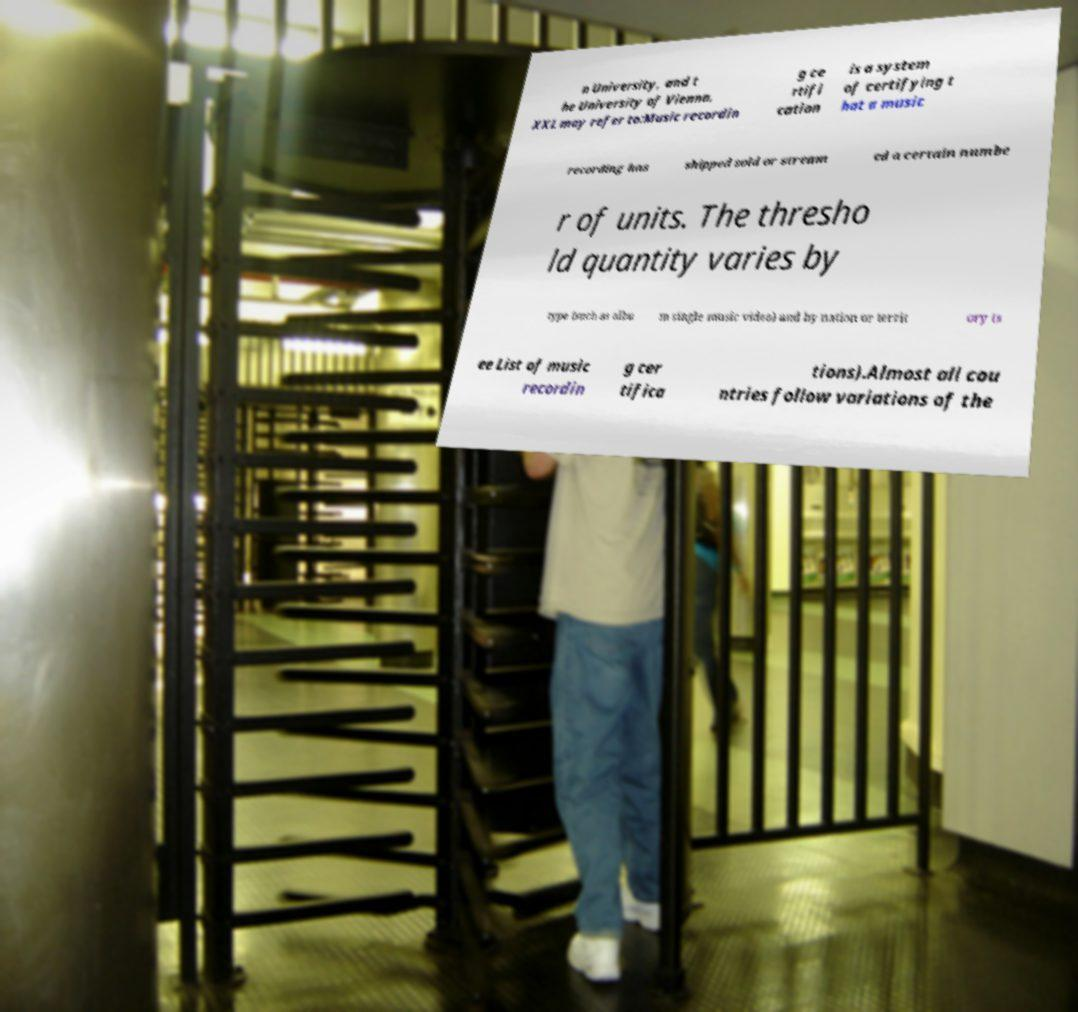Could you extract and type out the text from this image? n University, and t he University of Vienna. XXL may refer to:Music recordin g ce rtifi cation is a system of certifying t hat a music recording has shipped sold or stream ed a certain numbe r of units. The thresho ld quantity varies by type (such as albu m single music video) and by nation or territ ory (s ee List of music recordin g cer tifica tions).Almost all cou ntries follow variations of the 